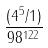Convert formula to latex. <formula><loc_0><loc_0><loc_500><loc_500>\frac { ( 4 ^ { 5 } / 1 ) } { 9 8 ^ { 1 2 2 } }</formula> 